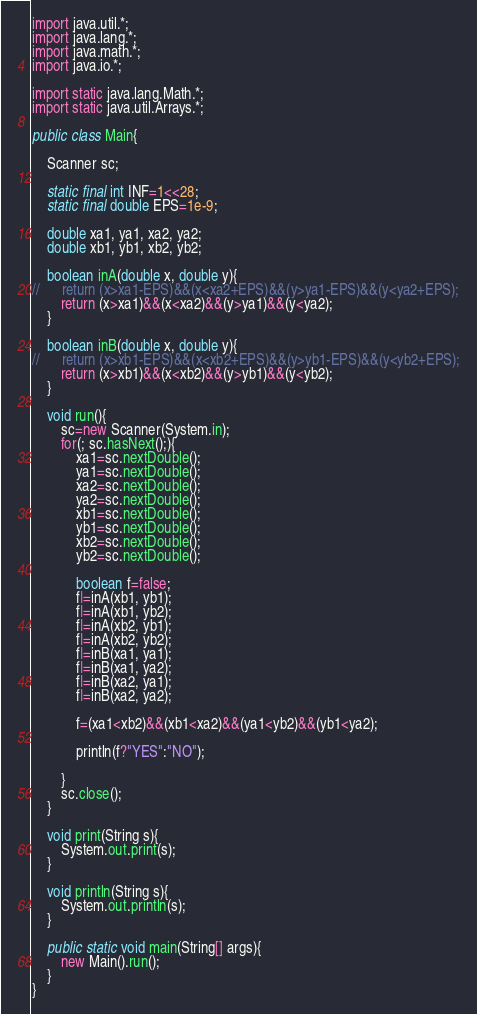<code> <loc_0><loc_0><loc_500><loc_500><_Java_>import java.util.*;
import java.lang.*;
import java.math.*;
import java.io.*;

import static java.lang.Math.*;
import static java.util.Arrays.*;

public class Main{

	Scanner sc;

	static final int INF=1<<28;
	static final double EPS=1e-9;

	double xa1, ya1, xa2, ya2;
	double xb1, yb1, xb2, yb2;

	boolean inA(double x, double y){
//		return (x>xa1-EPS)&&(x<xa2+EPS)&&(y>ya1-EPS)&&(y<ya2+EPS);
		return (x>xa1)&&(x<xa2)&&(y>ya1)&&(y<ya2);
	}

	boolean inB(double x, double y){
//		return (x>xb1-EPS)&&(x<xb2+EPS)&&(y>yb1-EPS)&&(y<yb2+EPS);
		return (x>xb1)&&(x<xb2)&&(y>yb1)&&(y<yb2);
	}

	void run(){
		sc=new Scanner(System.in);
		for(; sc.hasNext();){
			xa1=sc.nextDouble();
			ya1=sc.nextDouble();
			xa2=sc.nextDouble();
			ya2=sc.nextDouble();
			xb1=sc.nextDouble();
			yb1=sc.nextDouble();
			xb2=sc.nextDouble();
			yb2=sc.nextDouble();

			boolean f=false;
			f|=inA(xb1, yb1);
			f|=inA(xb1, yb2);
			f|=inA(xb2, yb1);
			f|=inA(xb2, yb2);
			f|=inB(xa1, ya1);
			f|=inB(xa1, ya2);
			f|=inB(xa2, ya1);
			f|=inB(xa2, ya2);

			f=(xa1<xb2)&&(xb1<xa2)&&(ya1<yb2)&&(yb1<ya2);
			
			println(f?"YES":"NO");

		}
		sc.close();
	}

	void print(String s){
		System.out.print(s);
	}

	void println(String s){
		System.out.println(s);
	}

	public static void main(String[] args){
		new Main().run();
	}
}</code> 